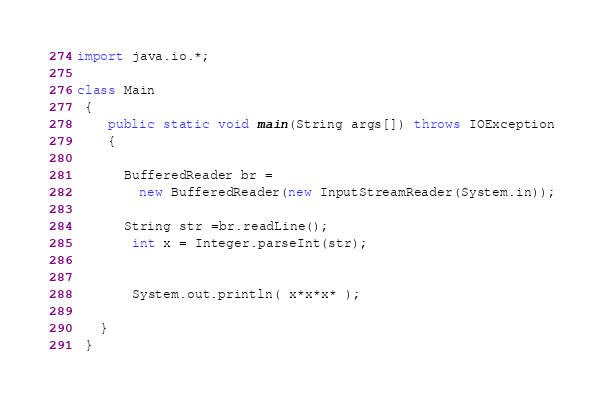Convert code to text. <code><loc_0><loc_0><loc_500><loc_500><_Java_>import java.io.*;

class Main
 {
    public static void main(String args[]) throws IOException
    {

      BufferedReader br =
        new BufferedReader(new InputStreamReader(System.in));

      String str =br.readLine();
       int x = Integer.parseInt(str);


       System.out.println( x*x*x* );

   }
 }</code> 